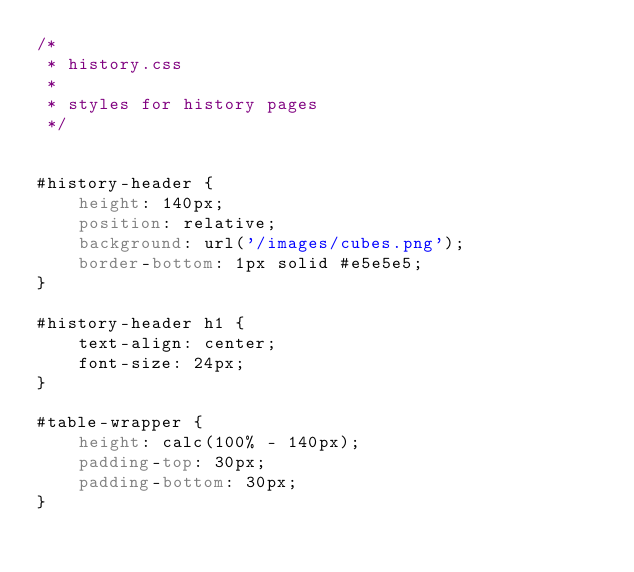Convert code to text. <code><loc_0><loc_0><loc_500><loc_500><_CSS_>/*
 * history.css
 *
 * styles for history pages
 */


#history-header {
    height: 140px;
    position: relative;
    background: url('/images/cubes.png');
    border-bottom: 1px solid #e5e5e5;
}

#history-header h1 {
    text-align: center;
    font-size: 24px;
}

#table-wrapper {
    height: calc(100% - 140px);
    padding-top: 30px;
    padding-bottom: 30px;
}
</code> 